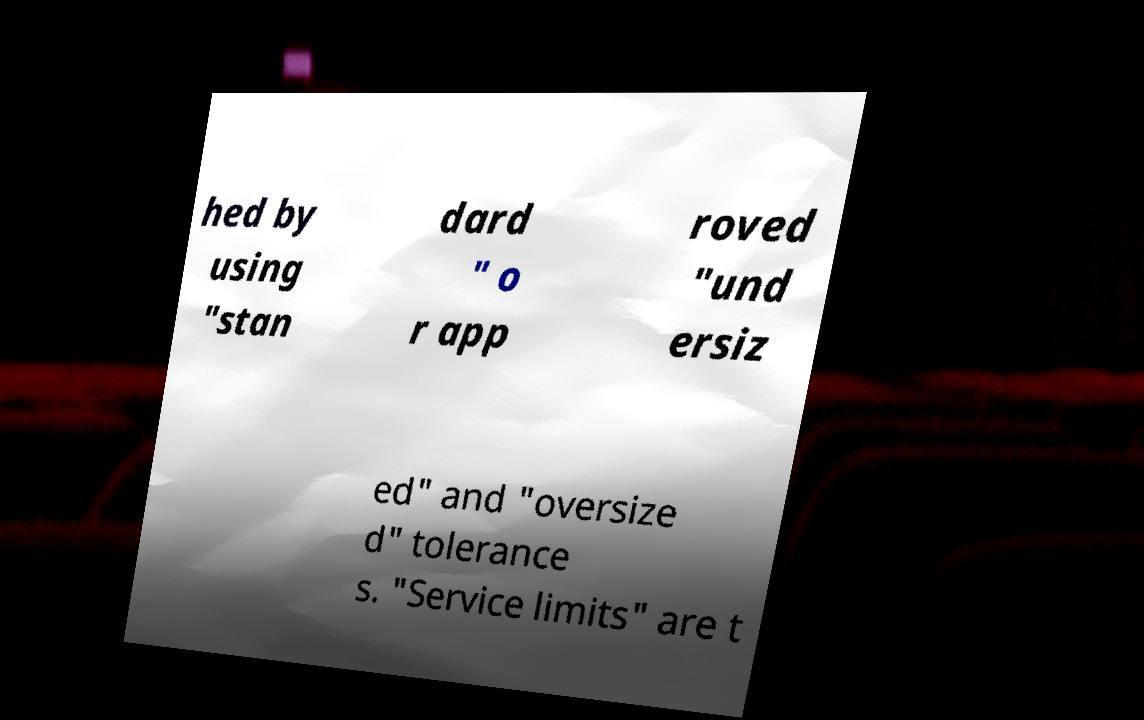Can you read and provide the text displayed in the image?This photo seems to have some interesting text. Can you extract and type it out for me? hed by using "stan dard " o r app roved "und ersiz ed" and "oversize d" tolerance s. "Service limits" are t 